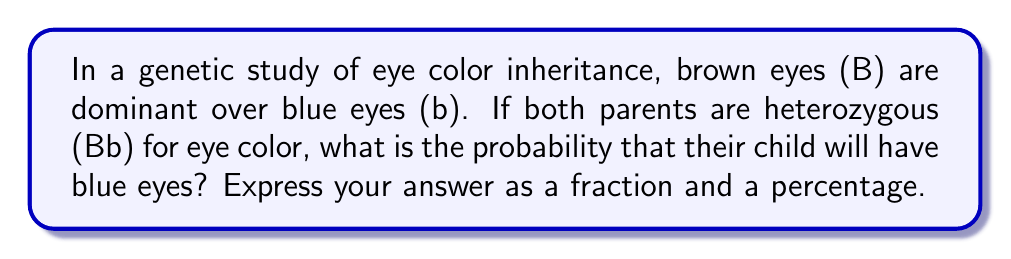Give your solution to this math problem. To solve this problem, we'll use a Punnett square and probability theory:

1. Construct a Punnett square:
   $$
   \begin{array}{c|cc}
     & B & b \\
   \hline
   B & BB & Bb \\
   b & Bb & bb
   \end{array}
   $$

2. Identify outcomes:
   - BB: Brown eyes (homozygous dominant)
   - Bb: Brown eyes (heterozygous)
   - bb: Blue eyes (homozygous recessive)

3. Count favorable outcomes:
   - There is 1 outcome (bb) that results in blue eyes.

4. Count total outcomes:
   - There are 4 total possible outcomes.

5. Calculate probability:
   $$P(\text{blue eyes}) = \frac{\text{favorable outcomes}}{\text{total outcomes}} = \frac{1}{4}$$

6. Convert to percentage:
   $$\frac{1}{4} \times 100\% = 25\%$$

Thus, the probability of the child having blue eyes is $\frac{1}{4}$ or 25%.
Answer: $\frac{1}{4}$ or 25% 